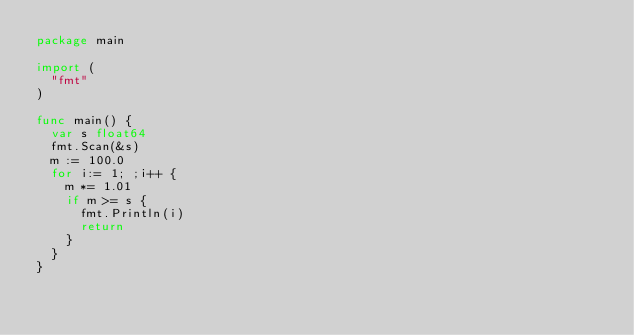Convert code to text. <code><loc_0><loc_0><loc_500><loc_500><_Go_>package main

import (
	"fmt"
)

func main() {
	var s float64
	fmt.Scan(&s)
	m := 100.0
	for i:= 1; ;i++ {
		m *= 1.01
		if m >= s {
			fmt.Println(i)
			return 
		}
	}
}
</code> 